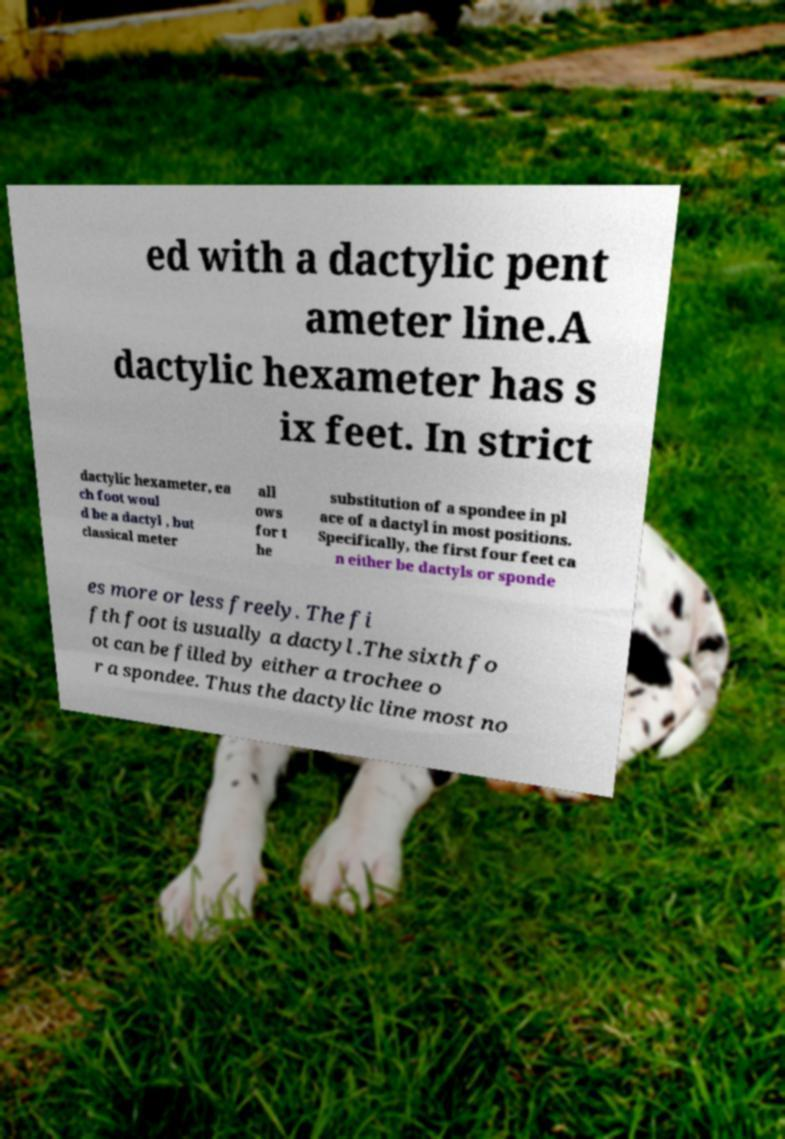Please read and relay the text visible in this image. What does it say? ed with a dactylic pent ameter line.A dactylic hexameter has s ix feet. In strict dactylic hexameter, ea ch foot woul d be a dactyl , but classical meter all ows for t he substitution of a spondee in pl ace of a dactyl in most positions. Specifically, the first four feet ca n either be dactyls or sponde es more or less freely. The fi fth foot is usually a dactyl .The sixth fo ot can be filled by either a trochee o r a spondee. Thus the dactylic line most no 